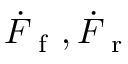Convert formula to latex. <formula><loc_0><loc_0><loc_500><loc_500>\dot { F } _ { f } , \dot { F } _ { r }</formula> 